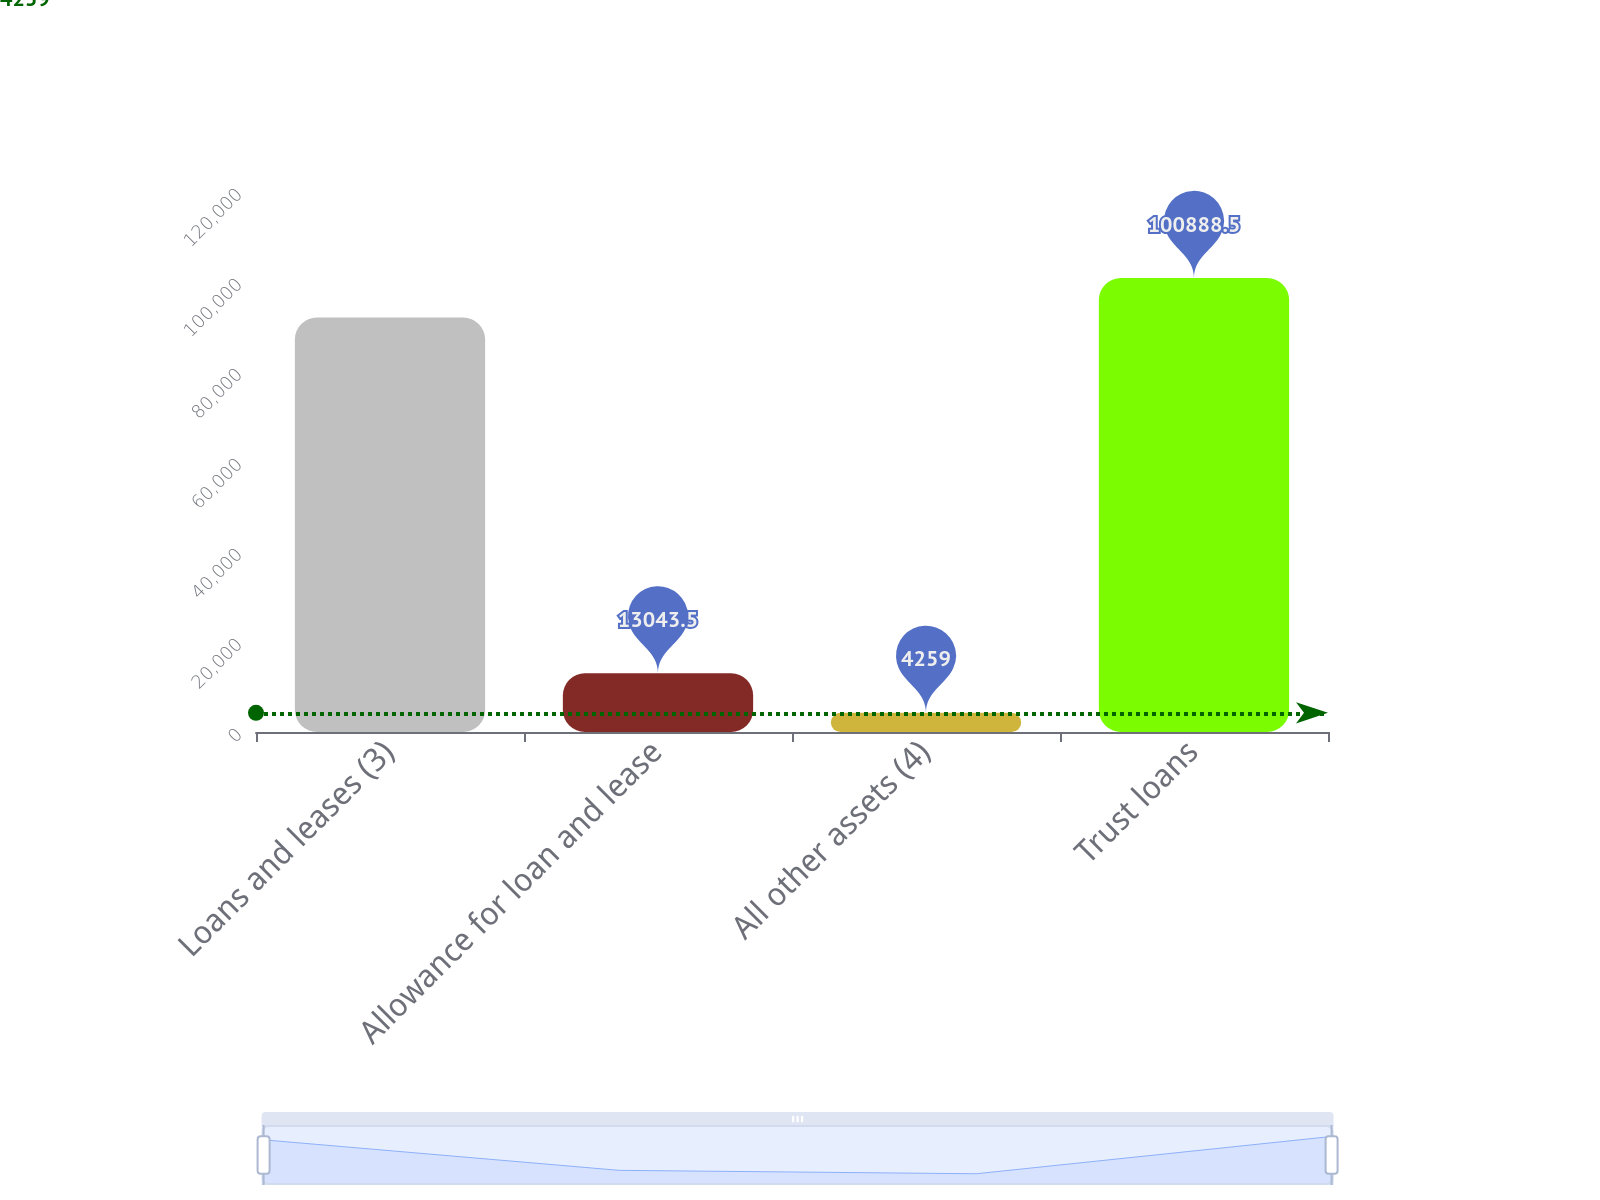Convert chart. <chart><loc_0><loc_0><loc_500><loc_500><bar_chart><fcel>Loans and leases (3)<fcel>Allowance for loan and lease<fcel>All other assets (4)<fcel>Trust loans<nl><fcel>92104<fcel>13043.5<fcel>4259<fcel>100888<nl></chart> 